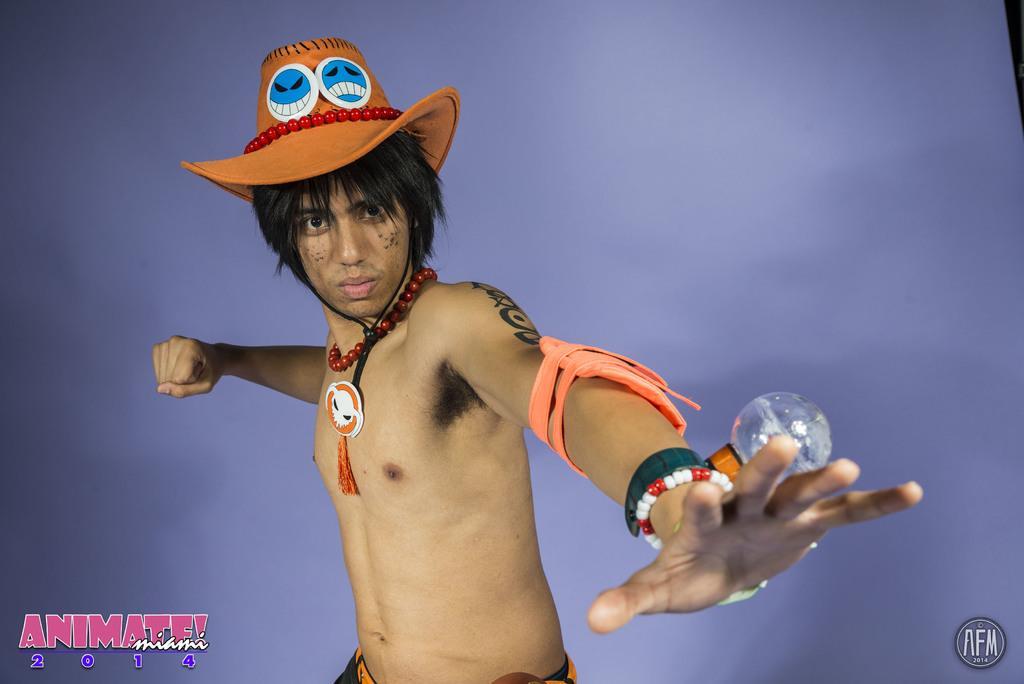In one or two sentences, can you explain what this image depicts? In this image there is a person wearing the cap. Behind him there is a wall. At the bottom of the image there are watermark, text, numbers on the image. 